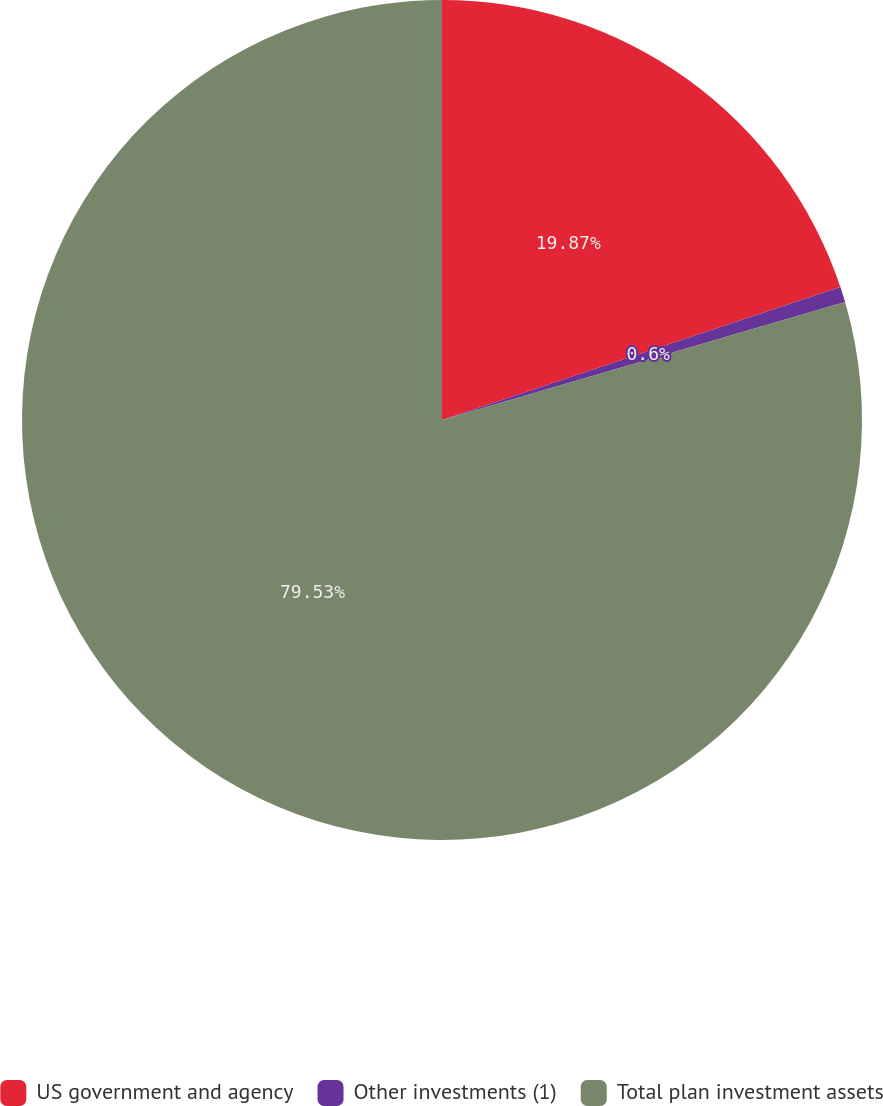Convert chart. <chart><loc_0><loc_0><loc_500><loc_500><pie_chart><fcel>US government and agency<fcel>Other investments (1)<fcel>Total plan investment assets<nl><fcel>19.87%<fcel>0.6%<fcel>79.53%<nl></chart> 